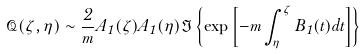<formula> <loc_0><loc_0><loc_500><loc_500>\mathcal { Q } ( \zeta , \eta ) \sim \frac { 2 } { m } A _ { 1 } ( \zeta ) A _ { 1 } ( \eta ) \Im \left \{ \exp \left [ - m \int _ { \eta } ^ { \zeta } B _ { 1 } ( t ) d t \right ] \right \}</formula> 